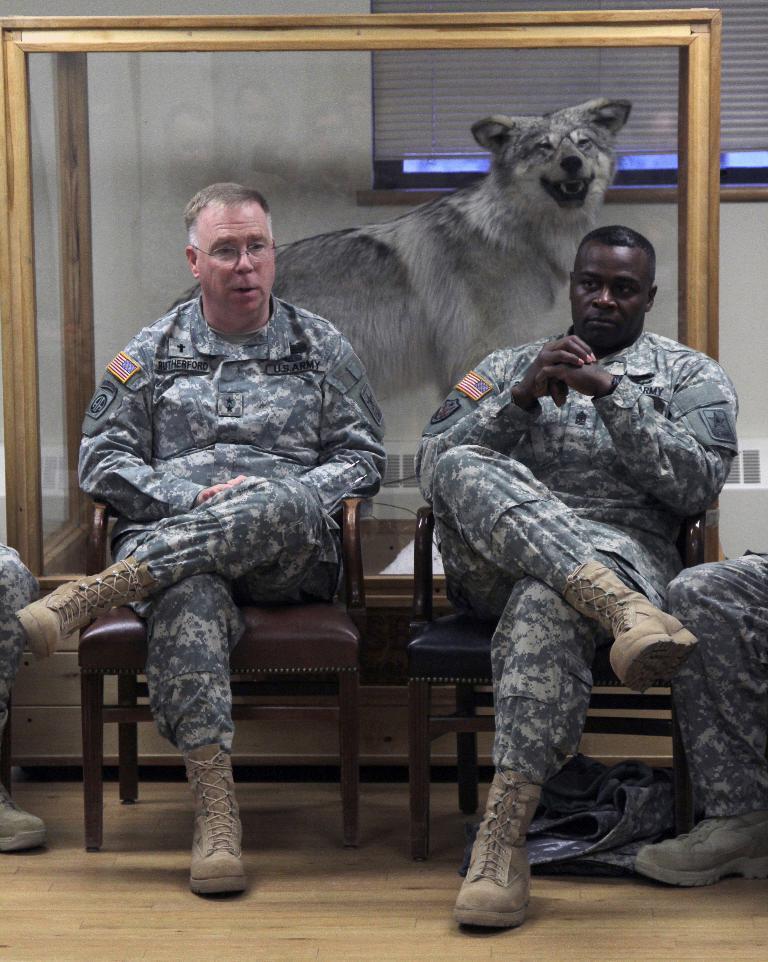Please provide a concise description of this image. In this image we can see some soldiers sitting on chairs and at the background of the image there is animal, wall and curtain. 